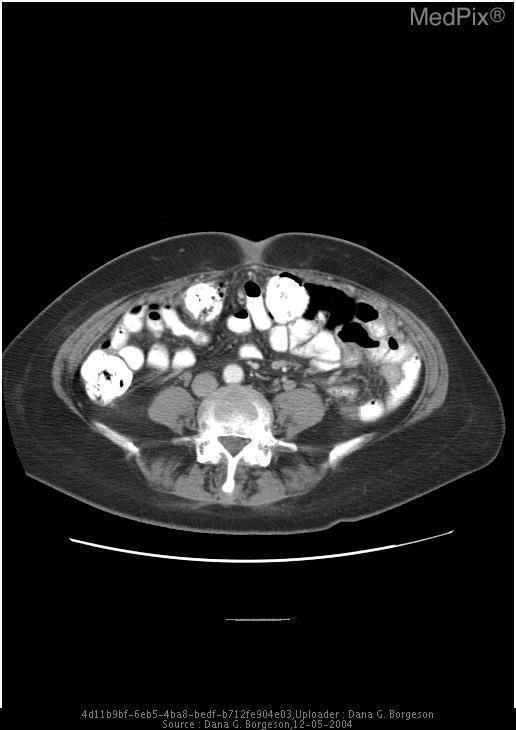Where can omental caking be seen in this image?
Be succinct. Left lateral aspect of anterior peritoneum. What abnormality can be seen in the greater omentum?
Short answer required. Omental caking. Is this a contrast enhanced image?
Quick response, please. Yes. 